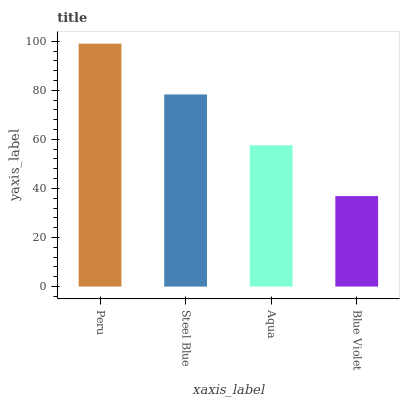Is Steel Blue the minimum?
Answer yes or no. No. Is Steel Blue the maximum?
Answer yes or no. No. Is Peru greater than Steel Blue?
Answer yes or no. Yes. Is Steel Blue less than Peru?
Answer yes or no. Yes. Is Steel Blue greater than Peru?
Answer yes or no. No. Is Peru less than Steel Blue?
Answer yes or no. No. Is Steel Blue the high median?
Answer yes or no. Yes. Is Aqua the low median?
Answer yes or no. Yes. Is Blue Violet the high median?
Answer yes or no. No. Is Blue Violet the low median?
Answer yes or no. No. 